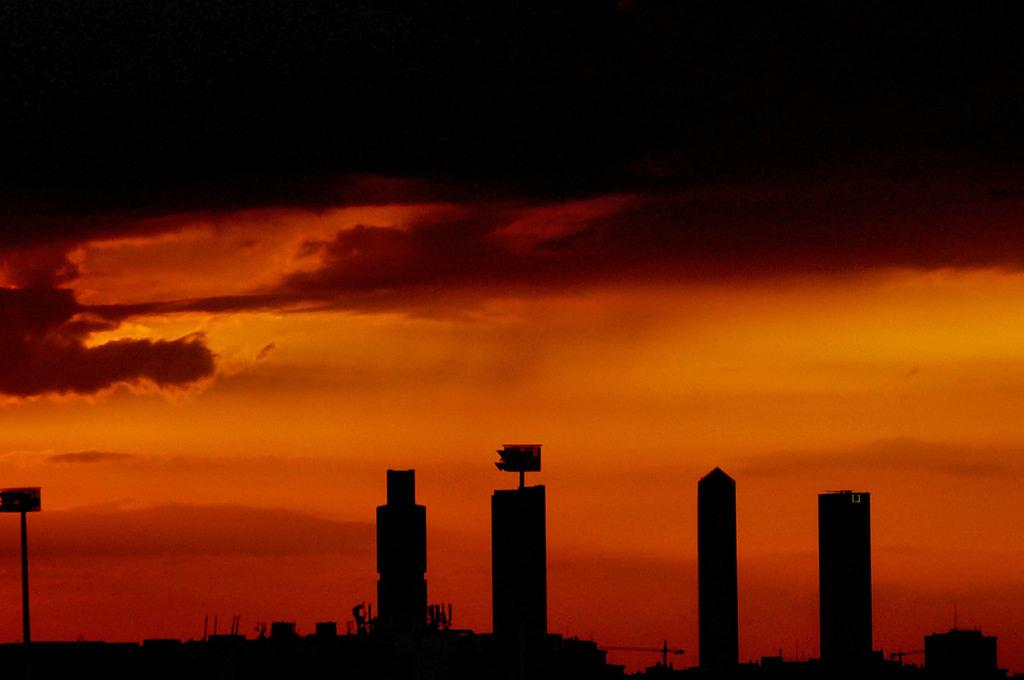What type of structures can be seen in the image? There are buildings in the image. What is the color of the sky in the image? The sky appears to be red in color. How many ladybugs can be seen on the buildings in the image? There are no ladybugs present in the image; it only features buildings and a red sky. 